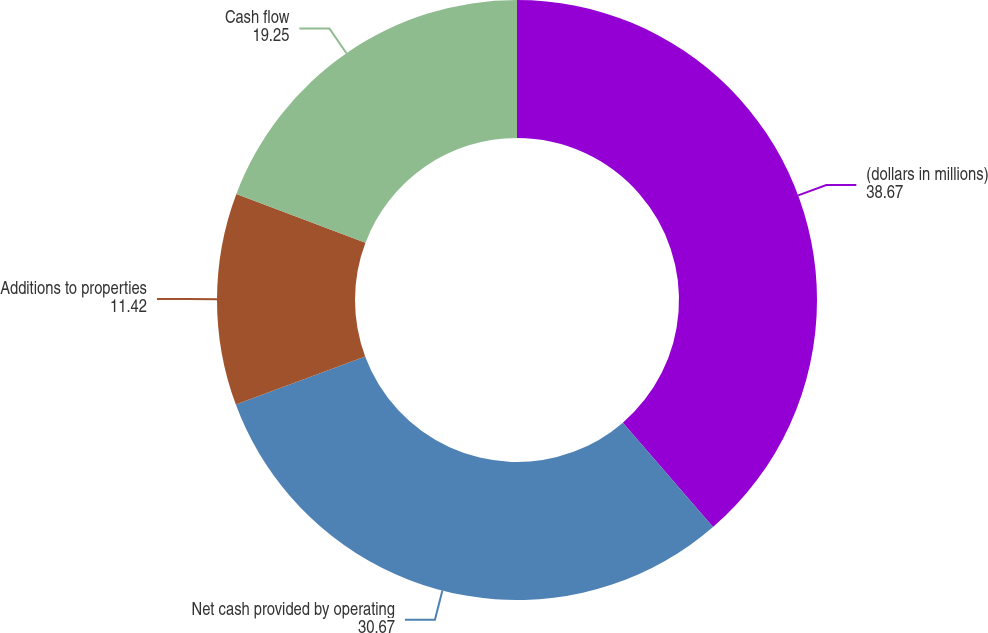Convert chart. <chart><loc_0><loc_0><loc_500><loc_500><pie_chart><fcel>(dollars in millions)<fcel>Net cash provided by operating<fcel>Additions to properties<fcel>Cash flow<nl><fcel>38.67%<fcel>30.67%<fcel>11.42%<fcel>19.25%<nl></chart> 